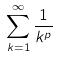Convert formula to latex. <formula><loc_0><loc_0><loc_500><loc_500>\sum _ { k = 1 } ^ { \infty } \frac { 1 } { k ^ { p } }</formula> 